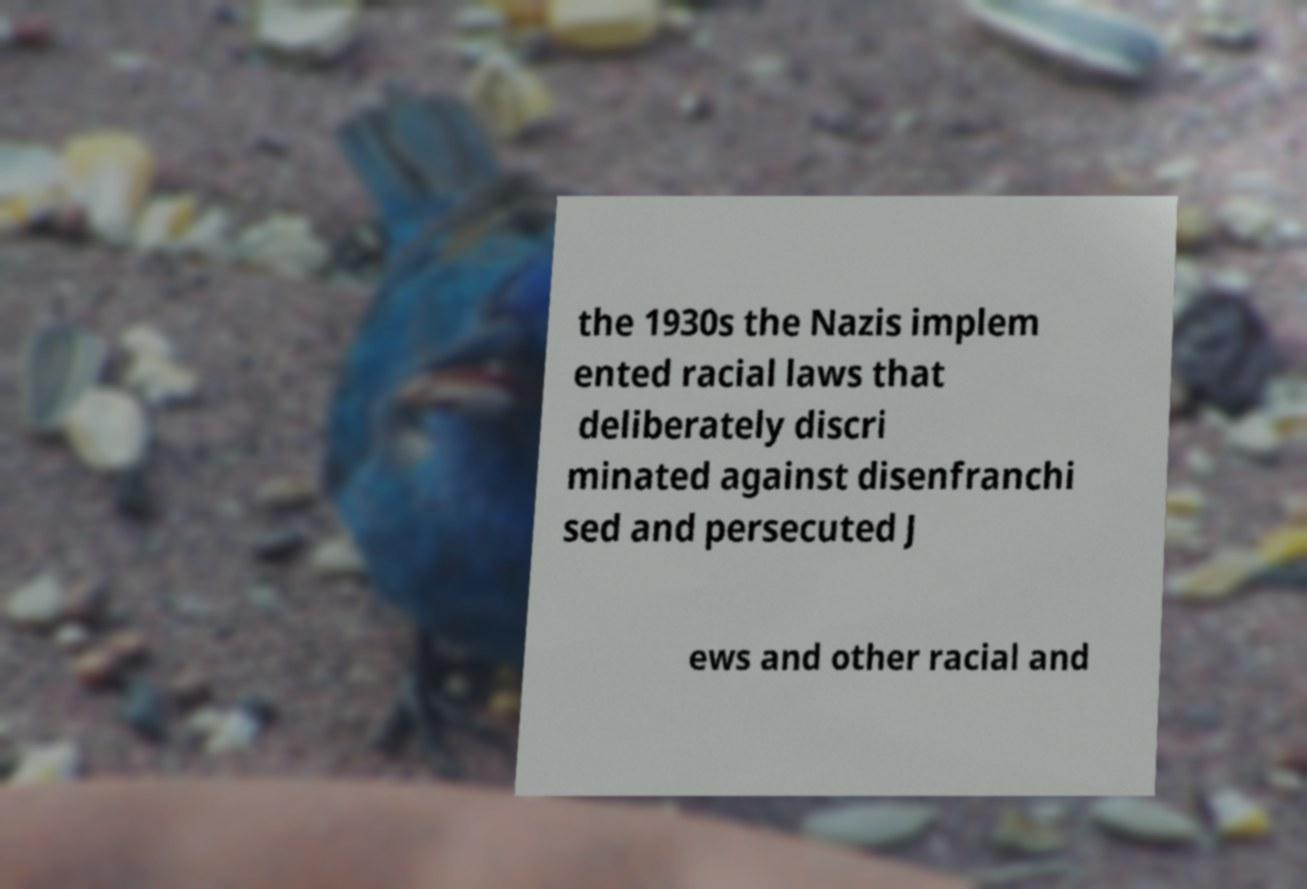Could you assist in decoding the text presented in this image and type it out clearly? the 1930s the Nazis implem ented racial laws that deliberately discri minated against disenfranchi sed and persecuted J ews and other racial and 